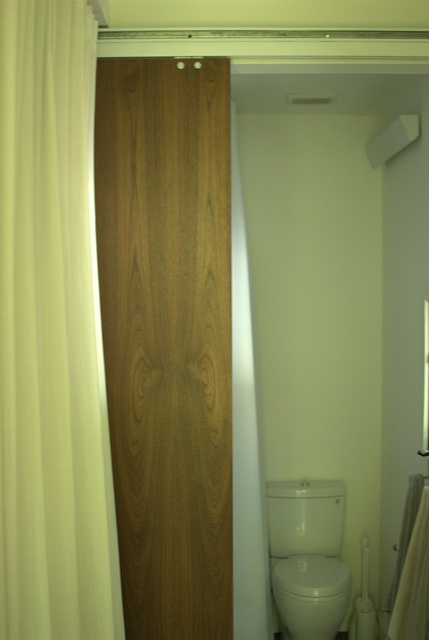Describe the objects in this image and their specific colors. I can see a toilet in olive, darkgreen, and black tones in this image. 